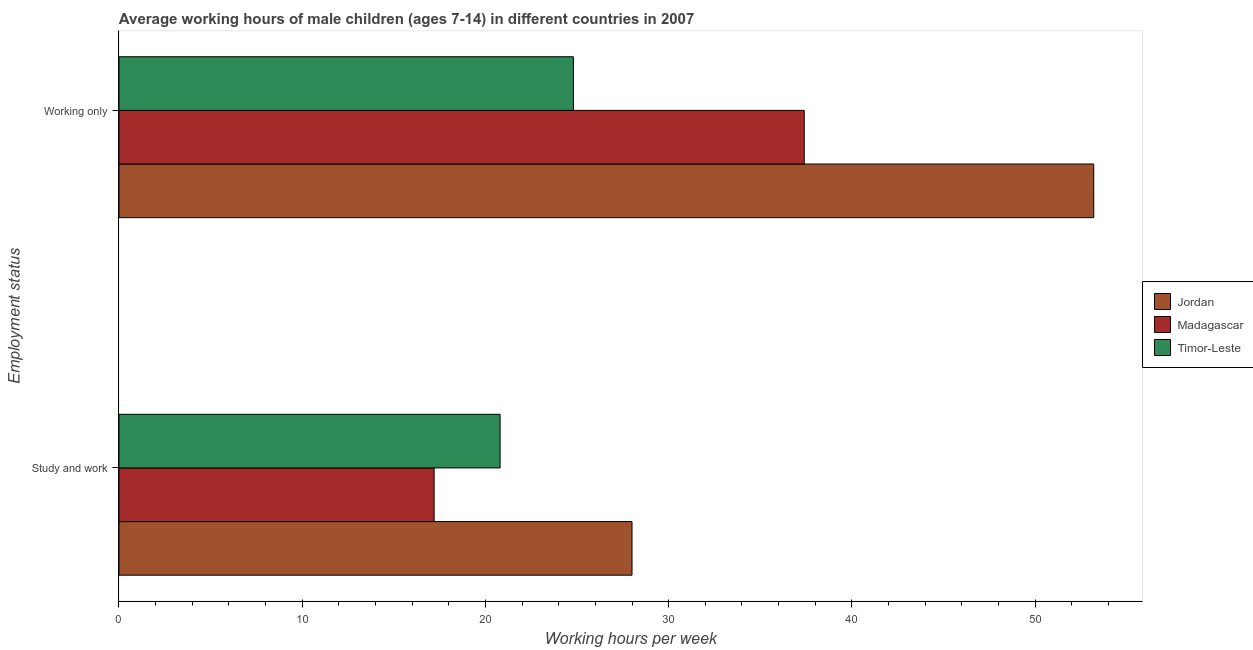How many groups of bars are there?
Give a very brief answer. 2. Are the number of bars on each tick of the Y-axis equal?
Your answer should be compact. Yes. How many bars are there on the 1st tick from the bottom?
Your answer should be very brief. 3. What is the label of the 2nd group of bars from the top?
Your answer should be very brief. Study and work. Across all countries, what is the maximum average working hour of children involved in only work?
Give a very brief answer. 53.2. Across all countries, what is the minimum average working hour of children involved in only work?
Your answer should be compact. 24.8. In which country was the average working hour of children involved in only work maximum?
Ensure brevity in your answer.  Jordan. In which country was the average working hour of children involved in only work minimum?
Ensure brevity in your answer.  Timor-Leste. What is the difference between the average working hour of children involved in only work in Timor-Leste and that in Jordan?
Your response must be concise. -28.4. What is the difference between the average working hour of children involved in only work in Jordan and the average working hour of children involved in study and work in Madagascar?
Provide a succinct answer. 36. What is the average average working hour of children involved in only work per country?
Your answer should be compact. 38.47. What is the difference between the average working hour of children involved in study and work and average working hour of children involved in only work in Jordan?
Offer a very short reply. -25.2. In how many countries, is the average working hour of children involved in study and work greater than 28 hours?
Your answer should be compact. 0. What is the ratio of the average working hour of children involved in study and work in Madagascar to that in Timor-Leste?
Ensure brevity in your answer.  0.83. In how many countries, is the average working hour of children involved in study and work greater than the average average working hour of children involved in study and work taken over all countries?
Offer a very short reply. 1. What does the 3rd bar from the top in Working only represents?
Provide a short and direct response. Jordan. What does the 2nd bar from the bottom in Working only represents?
Ensure brevity in your answer.  Madagascar. How many countries are there in the graph?
Your response must be concise. 3. What is the difference between two consecutive major ticks on the X-axis?
Offer a terse response. 10. Are the values on the major ticks of X-axis written in scientific E-notation?
Your answer should be compact. No. Does the graph contain any zero values?
Make the answer very short. No. Does the graph contain grids?
Your answer should be very brief. No. How are the legend labels stacked?
Your answer should be compact. Vertical. What is the title of the graph?
Offer a terse response. Average working hours of male children (ages 7-14) in different countries in 2007. Does "Grenada" appear as one of the legend labels in the graph?
Your answer should be very brief. No. What is the label or title of the X-axis?
Ensure brevity in your answer.  Working hours per week. What is the label or title of the Y-axis?
Your answer should be compact. Employment status. What is the Working hours per week in Madagascar in Study and work?
Offer a terse response. 17.2. What is the Working hours per week of Timor-Leste in Study and work?
Your response must be concise. 20.8. What is the Working hours per week in Jordan in Working only?
Provide a succinct answer. 53.2. What is the Working hours per week in Madagascar in Working only?
Offer a very short reply. 37.4. What is the Working hours per week of Timor-Leste in Working only?
Provide a short and direct response. 24.8. Across all Employment status, what is the maximum Working hours per week in Jordan?
Provide a succinct answer. 53.2. Across all Employment status, what is the maximum Working hours per week of Madagascar?
Make the answer very short. 37.4. Across all Employment status, what is the maximum Working hours per week of Timor-Leste?
Offer a terse response. 24.8. Across all Employment status, what is the minimum Working hours per week of Timor-Leste?
Your answer should be very brief. 20.8. What is the total Working hours per week of Jordan in the graph?
Your response must be concise. 81.2. What is the total Working hours per week of Madagascar in the graph?
Offer a very short reply. 54.6. What is the total Working hours per week of Timor-Leste in the graph?
Your answer should be very brief. 45.6. What is the difference between the Working hours per week in Jordan in Study and work and that in Working only?
Your answer should be very brief. -25.2. What is the difference between the Working hours per week in Madagascar in Study and work and that in Working only?
Give a very brief answer. -20.2. What is the difference between the Working hours per week in Timor-Leste in Study and work and that in Working only?
Give a very brief answer. -4. What is the difference between the Working hours per week of Jordan in Study and work and the Working hours per week of Timor-Leste in Working only?
Your answer should be compact. 3.2. What is the difference between the Working hours per week in Madagascar in Study and work and the Working hours per week in Timor-Leste in Working only?
Your answer should be compact. -7.6. What is the average Working hours per week of Jordan per Employment status?
Provide a short and direct response. 40.6. What is the average Working hours per week in Madagascar per Employment status?
Make the answer very short. 27.3. What is the average Working hours per week of Timor-Leste per Employment status?
Offer a terse response. 22.8. What is the difference between the Working hours per week of Jordan and Working hours per week of Madagascar in Working only?
Ensure brevity in your answer.  15.8. What is the difference between the Working hours per week in Jordan and Working hours per week in Timor-Leste in Working only?
Your response must be concise. 28.4. What is the difference between the Working hours per week in Madagascar and Working hours per week in Timor-Leste in Working only?
Make the answer very short. 12.6. What is the ratio of the Working hours per week of Jordan in Study and work to that in Working only?
Offer a terse response. 0.53. What is the ratio of the Working hours per week of Madagascar in Study and work to that in Working only?
Your response must be concise. 0.46. What is the ratio of the Working hours per week of Timor-Leste in Study and work to that in Working only?
Offer a terse response. 0.84. What is the difference between the highest and the second highest Working hours per week in Jordan?
Offer a very short reply. 25.2. What is the difference between the highest and the second highest Working hours per week of Madagascar?
Keep it short and to the point. 20.2. What is the difference between the highest and the second highest Working hours per week in Timor-Leste?
Your response must be concise. 4. What is the difference between the highest and the lowest Working hours per week of Jordan?
Keep it short and to the point. 25.2. What is the difference between the highest and the lowest Working hours per week of Madagascar?
Offer a terse response. 20.2. 